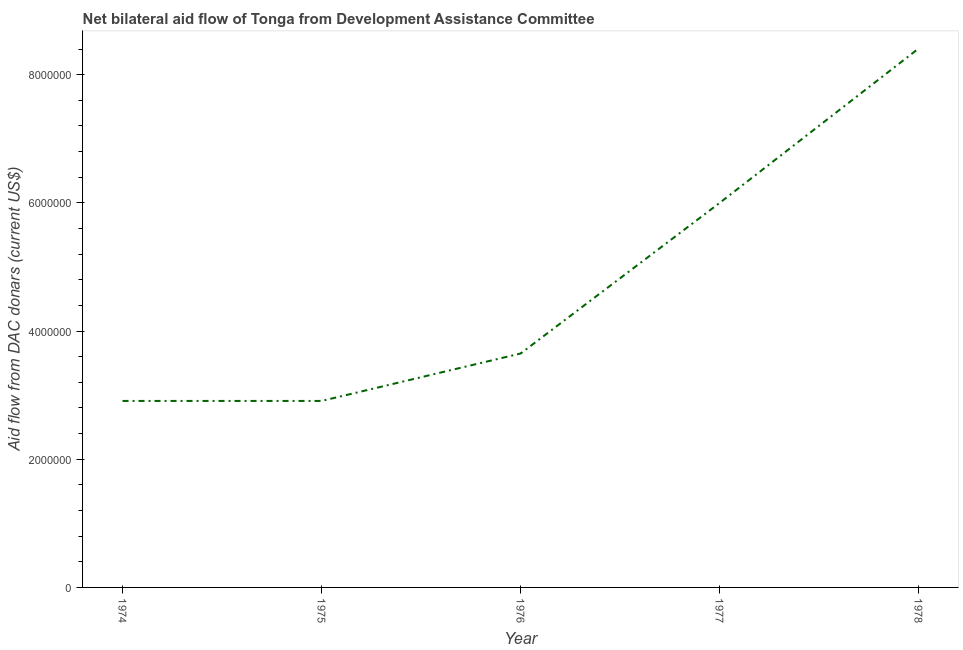What is the net bilateral aid flows from dac donors in 1977?
Provide a succinct answer. 6.00e+06. Across all years, what is the maximum net bilateral aid flows from dac donors?
Your response must be concise. 8.41e+06. Across all years, what is the minimum net bilateral aid flows from dac donors?
Your answer should be very brief. 2.91e+06. In which year was the net bilateral aid flows from dac donors maximum?
Give a very brief answer. 1978. In which year was the net bilateral aid flows from dac donors minimum?
Keep it short and to the point. 1974. What is the sum of the net bilateral aid flows from dac donors?
Make the answer very short. 2.39e+07. What is the difference between the net bilateral aid flows from dac donors in 1977 and 1978?
Offer a terse response. -2.41e+06. What is the average net bilateral aid flows from dac donors per year?
Keep it short and to the point. 4.78e+06. What is the median net bilateral aid flows from dac donors?
Offer a very short reply. 3.65e+06. In how many years, is the net bilateral aid flows from dac donors greater than 6000000 US$?
Offer a very short reply. 1. What is the ratio of the net bilateral aid flows from dac donors in 1977 to that in 1978?
Provide a short and direct response. 0.71. Is the net bilateral aid flows from dac donors in 1975 less than that in 1977?
Provide a short and direct response. Yes. Is the difference between the net bilateral aid flows from dac donors in 1974 and 1976 greater than the difference between any two years?
Provide a succinct answer. No. What is the difference between the highest and the second highest net bilateral aid flows from dac donors?
Provide a succinct answer. 2.41e+06. Is the sum of the net bilateral aid flows from dac donors in 1977 and 1978 greater than the maximum net bilateral aid flows from dac donors across all years?
Your response must be concise. Yes. What is the difference between the highest and the lowest net bilateral aid flows from dac donors?
Ensure brevity in your answer.  5.50e+06. Does the net bilateral aid flows from dac donors monotonically increase over the years?
Give a very brief answer. No. How many lines are there?
Give a very brief answer. 1. What is the title of the graph?
Provide a succinct answer. Net bilateral aid flow of Tonga from Development Assistance Committee. What is the label or title of the X-axis?
Your answer should be compact. Year. What is the label or title of the Y-axis?
Your answer should be very brief. Aid flow from DAC donars (current US$). What is the Aid flow from DAC donars (current US$) in 1974?
Your response must be concise. 2.91e+06. What is the Aid flow from DAC donars (current US$) of 1975?
Your answer should be compact. 2.91e+06. What is the Aid flow from DAC donars (current US$) of 1976?
Ensure brevity in your answer.  3.65e+06. What is the Aid flow from DAC donars (current US$) of 1978?
Make the answer very short. 8.41e+06. What is the difference between the Aid flow from DAC donars (current US$) in 1974 and 1976?
Make the answer very short. -7.40e+05. What is the difference between the Aid flow from DAC donars (current US$) in 1974 and 1977?
Your answer should be compact. -3.09e+06. What is the difference between the Aid flow from DAC donars (current US$) in 1974 and 1978?
Your response must be concise. -5.50e+06. What is the difference between the Aid flow from DAC donars (current US$) in 1975 and 1976?
Provide a short and direct response. -7.40e+05. What is the difference between the Aid flow from DAC donars (current US$) in 1975 and 1977?
Give a very brief answer. -3.09e+06. What is the difference between the Aid flow from DAC donars (current US$) in 1975 and 1978?
Your answer should be very brief. -5.50e+06. What is the difference between the Aid flow from DAC donars (current US$) in 1976 and 1977?
Make the answer very short. -2.35e+06. What is the difference between the Aid flow from DAC donars (current US$) in 1976 and 1978?
Provide a short and direct response. -4.76e+06. What is the difference between the Aid flow from DAC donars (current US$) in 1977 and 1978?
Ensure brevity in your answer.  -2.41e+06. What is the ratio of the Aid flow from DAC donars (current US$) in 1974 to that in 1975?
Make the answer very short. 1. What is the ratio of the Aid flow from DAC donars (current US$) in 1974 to that in 1976?
Your answer should be compact. 0.8. What is the ratio of the Aid flow from DAC donars (current US$) in 1974 to that in 1977?
Keep it short and to the point. 0.48. What is the ratio of the Aid flow from DAC donars (current US$) in 1974 to that in 1978?
Make the answer very short. 0.35. What is the ratio of the Aid flow from DAC donars (current US$) in 1975 to that in 1976?
Offer a terse response. 0.8. What is the ratio of the Aid flow from DAC donars (current US$) in 1975 to that in 1977?
Your answer should be compact. 0.48. What is the ratio of the Aid flow from DAC donars (current US$) in 1975 to that in 1978?
Give a very brief answer. 0.35. What is the ratio of the Aid flow from DAC donars (current US$) in 1976 to that in 1977?
Provide a succinct answer. 0.61. What is the ratio of the Aid flow from DAC donars (current US$) in 1976 to that in 1978?
Make the answer very short. 0.43. What is the ratio of the Aid flow from DAC donars (current US$) in 1977 to that in 1978?
Your answer should be very brief. 0.71. 